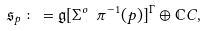<formula> <loc_0><loc_0><loc_500><loc_500>\mathfrak { s } _ { p } \colon = \mathfrak { g } [ { \Sigma } ^ { o } \ \pi ^ { - 1 } ( p ) ] ^ { \Gamma } \oplus \mathbb { C } C ,</formula> 